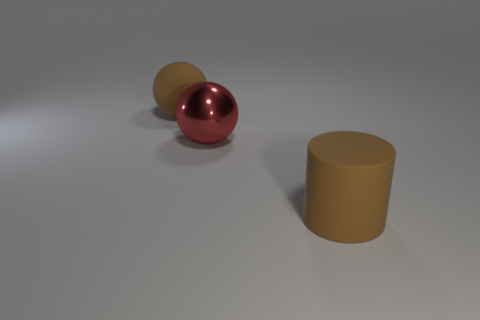Add 1 small red matte objects. How many objects exist? 4 Subtract all cylinders. How many objects are left? 2 Add 3 shiny objects. How many shiny objects exist? 4 Subtract 0 blue spheres. How many objects are left? 3 Subtract all metal spheres. Subtract all large rubber objects. How many objects are left? 0 Add 2 brown objects. How many brown objects are left? 4 